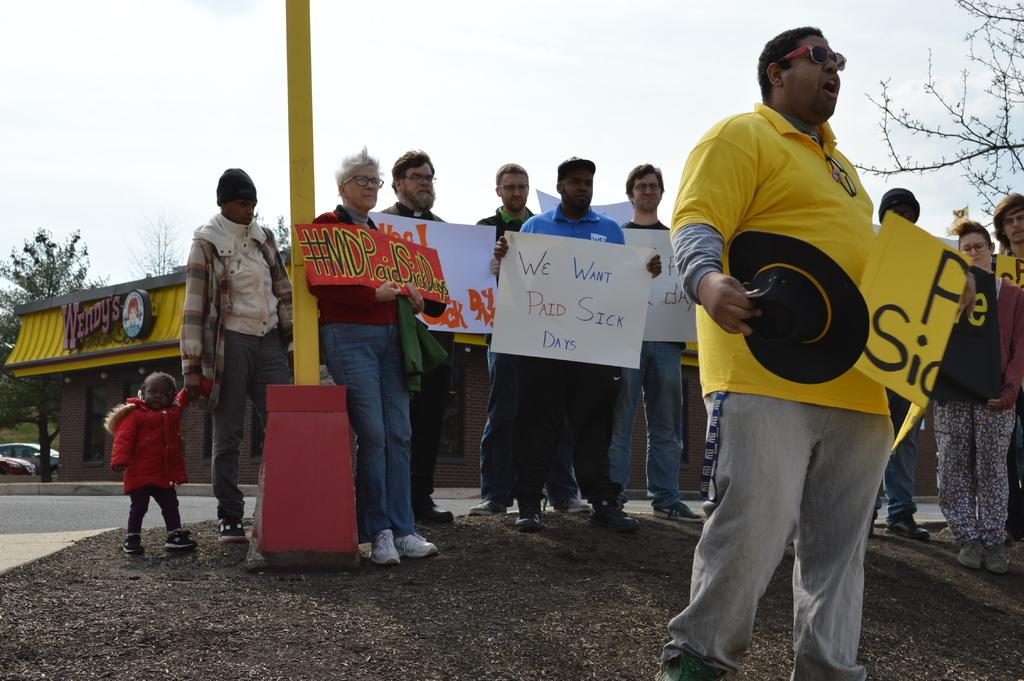What are the people in the image holding? The people in the image are holding posters. What type of structure can be seen in the image? There is a building in the image. What natural element is present in the image? There is a tree in the image. What mode of transportation is visible in the image? There is a vehicle in the image. What object can be seen on a path in the image? A pole is visible on a path in the image. How many feet are visible on the minister in the image? There is no minister present in the image, so it is not possible to determine the number of feet visible. 